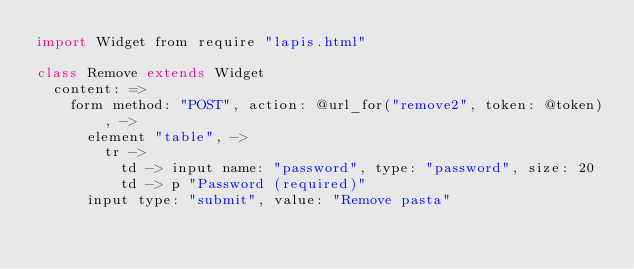Convert code to text. <code><loc_0><loc_0><loc_500><loc_500><_MoonScript_>import Widget from require "lapis.html"

class Remove extends Widget
  content: =>
    form method: "POST", action: @url_for("remove2", token: @token), ->
      element "table", ->
        tr ->
          td -> input name: "password", type: "password", size: 20
          td -> p "Password (required)"
      input type: "submit", value: "Remove pasta"
</code> 